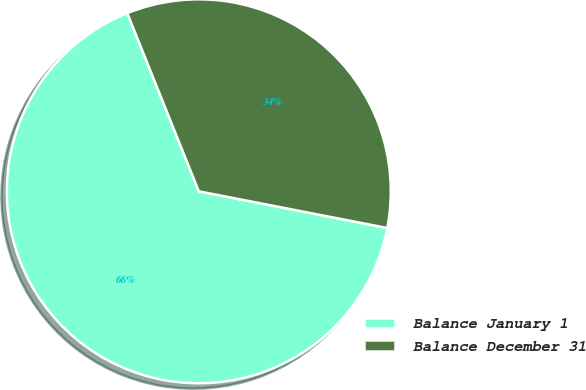Convert chart to OTSL. <chart><loc_0><loc_0><loc_500><loc_500><pie_chart><fcel>Balance January 1<fcel>Balance December 31<nl><fcel>65.86%<fcel>34.14%<nl></chart> 